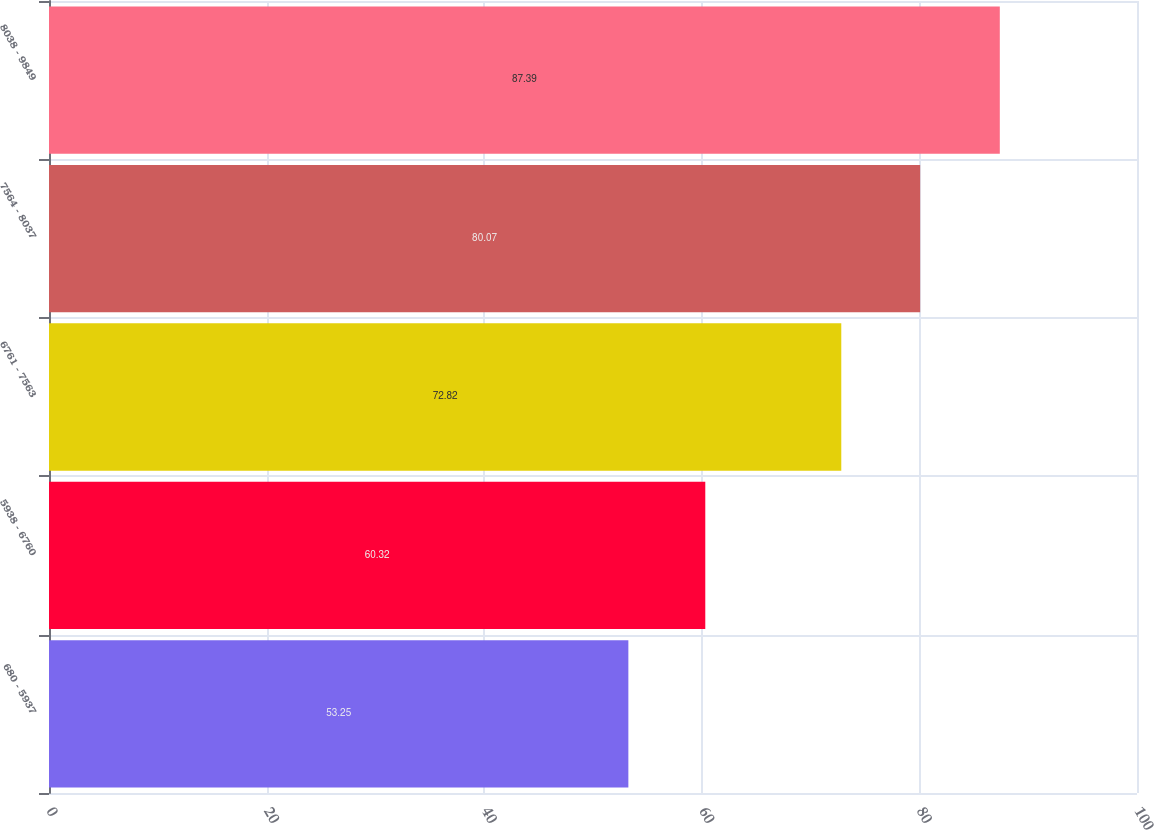Convert chart to OTSL. <chart><loc_0><loc_0><loc_500><loc_500><bar_chart><fcel>680 - 5937<fcel>5938 - 6760<fcel>6761 - 7563<fcel>7564 - 8037<fcel>8038 - 9849<nl><fcel>53.25<fcel>60.32<fcel>72.82<fcel>80.07<fcel>87.39<nl></chart> 